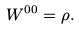<formula> <loc_0><loc_0><loc_500><loc_500>W ^ { 0 0 } = \rho .</formula> 